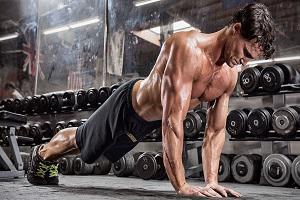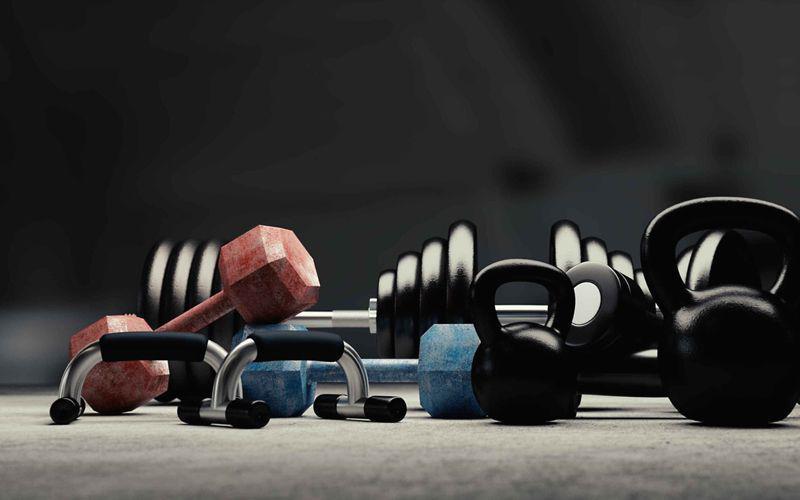The first image is the image on the left, the second image is the image on the right. Examine the images to the left and right. Is the description "One image shows a human doing pushups." accurate? Answer yes or no. Yes. The first image is the image on the left, the second image is the image on the right. Examine the images to the left and right. Is the description "There is at least one man visible exercising" accurate? Answer yes or no. Yes. 